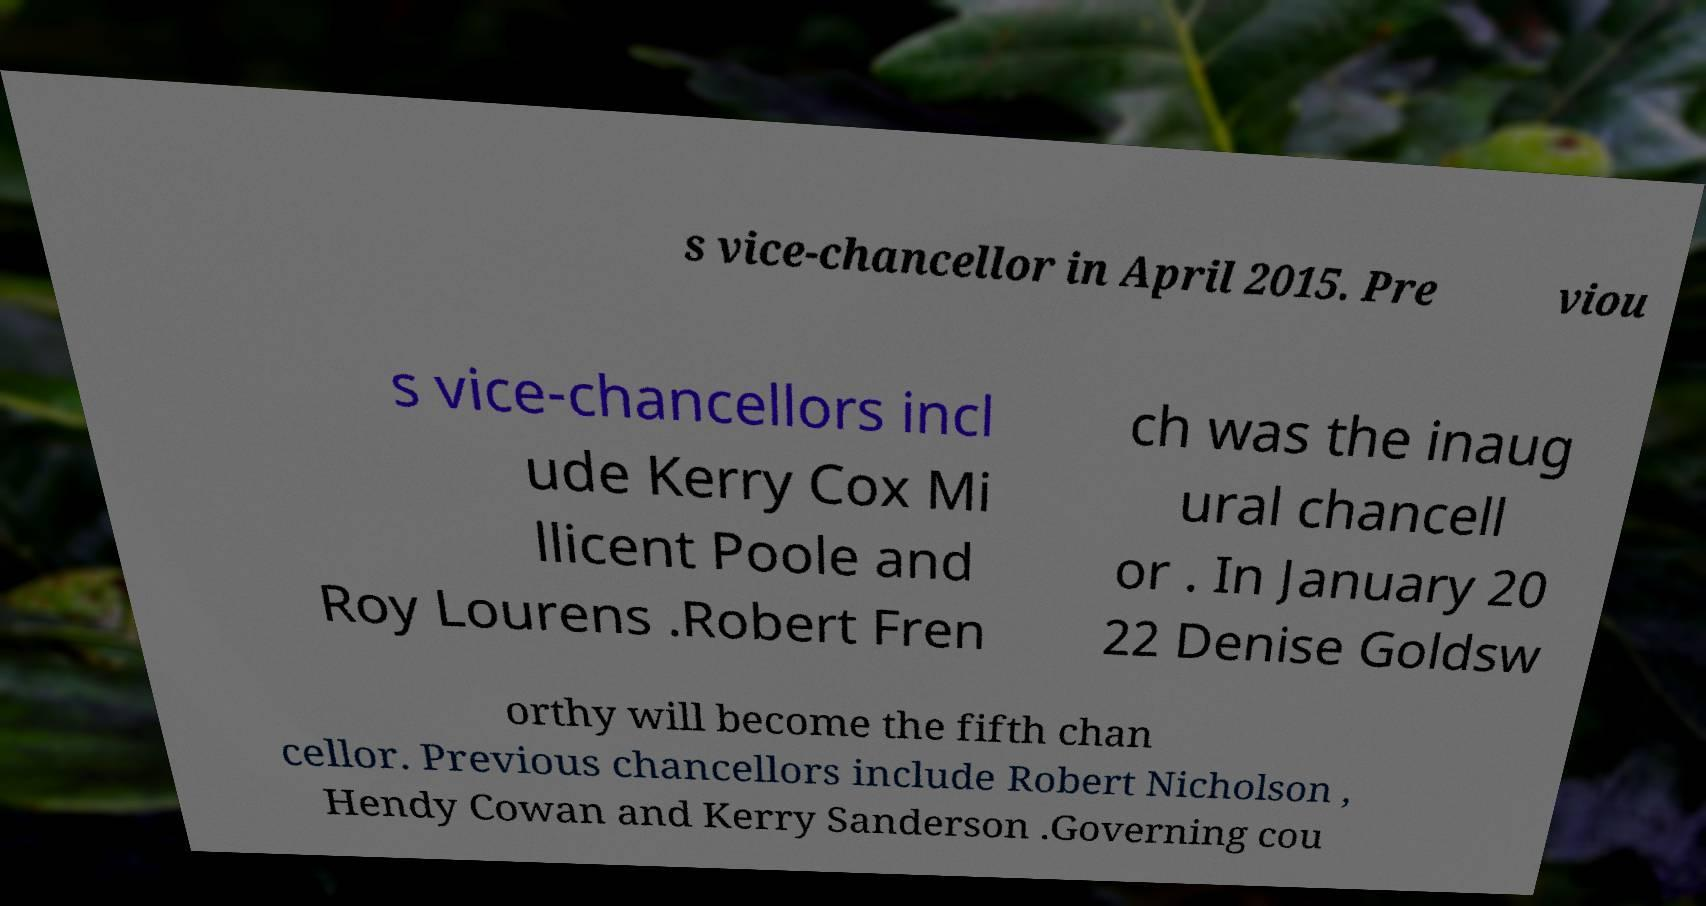There's text embedded in this image that I need extracted. Can you transcribe it verbatim? s vice-chancellor in April 2015. Pre viou s vice-chancellors incl ude Kerry Cox Mi llicent Poole and Roy Lourens .Robert Fren ch was the inaug ural chancell or . In January 20 22 Denise Goldsw orthy will become the fifth chan cellor. Previous chancellors include Robert Nicholson , Hendy Cowan and Kerry Sanderson .Governing cou 